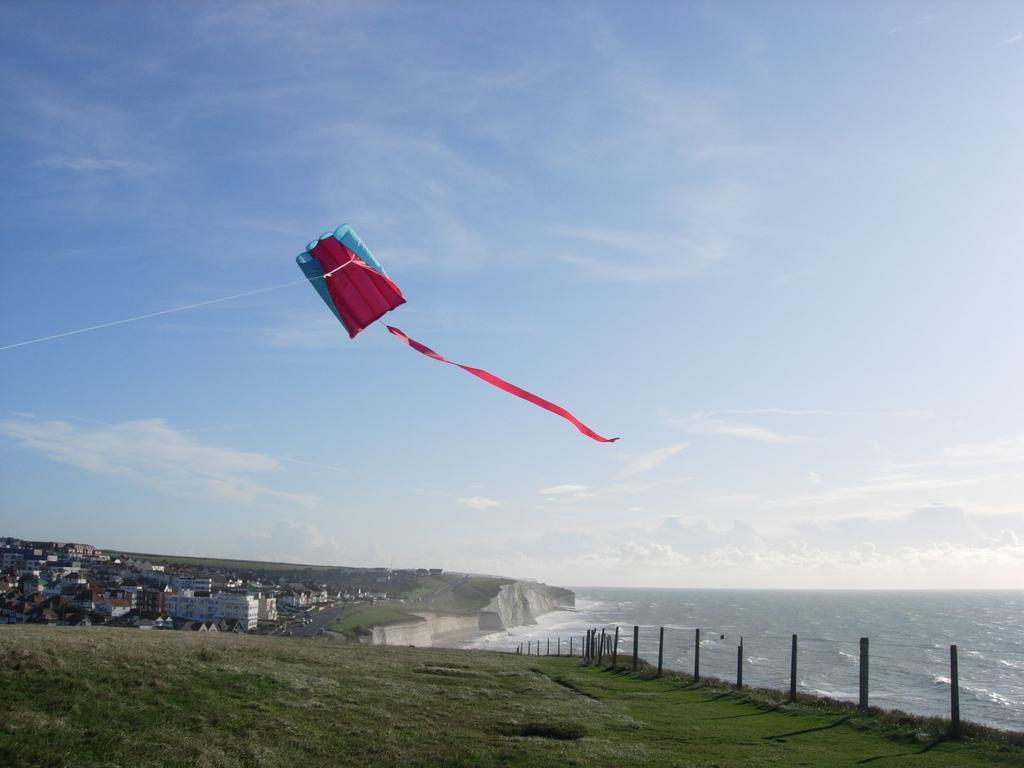How would you summarize this image in a sentence or two? In this picture we can see a kite flying, buildings, water, fence, grass and in the background we can see the sky with clouds. 